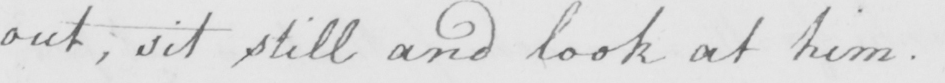What does this handwritten line say? out  , sit still and look at him . 